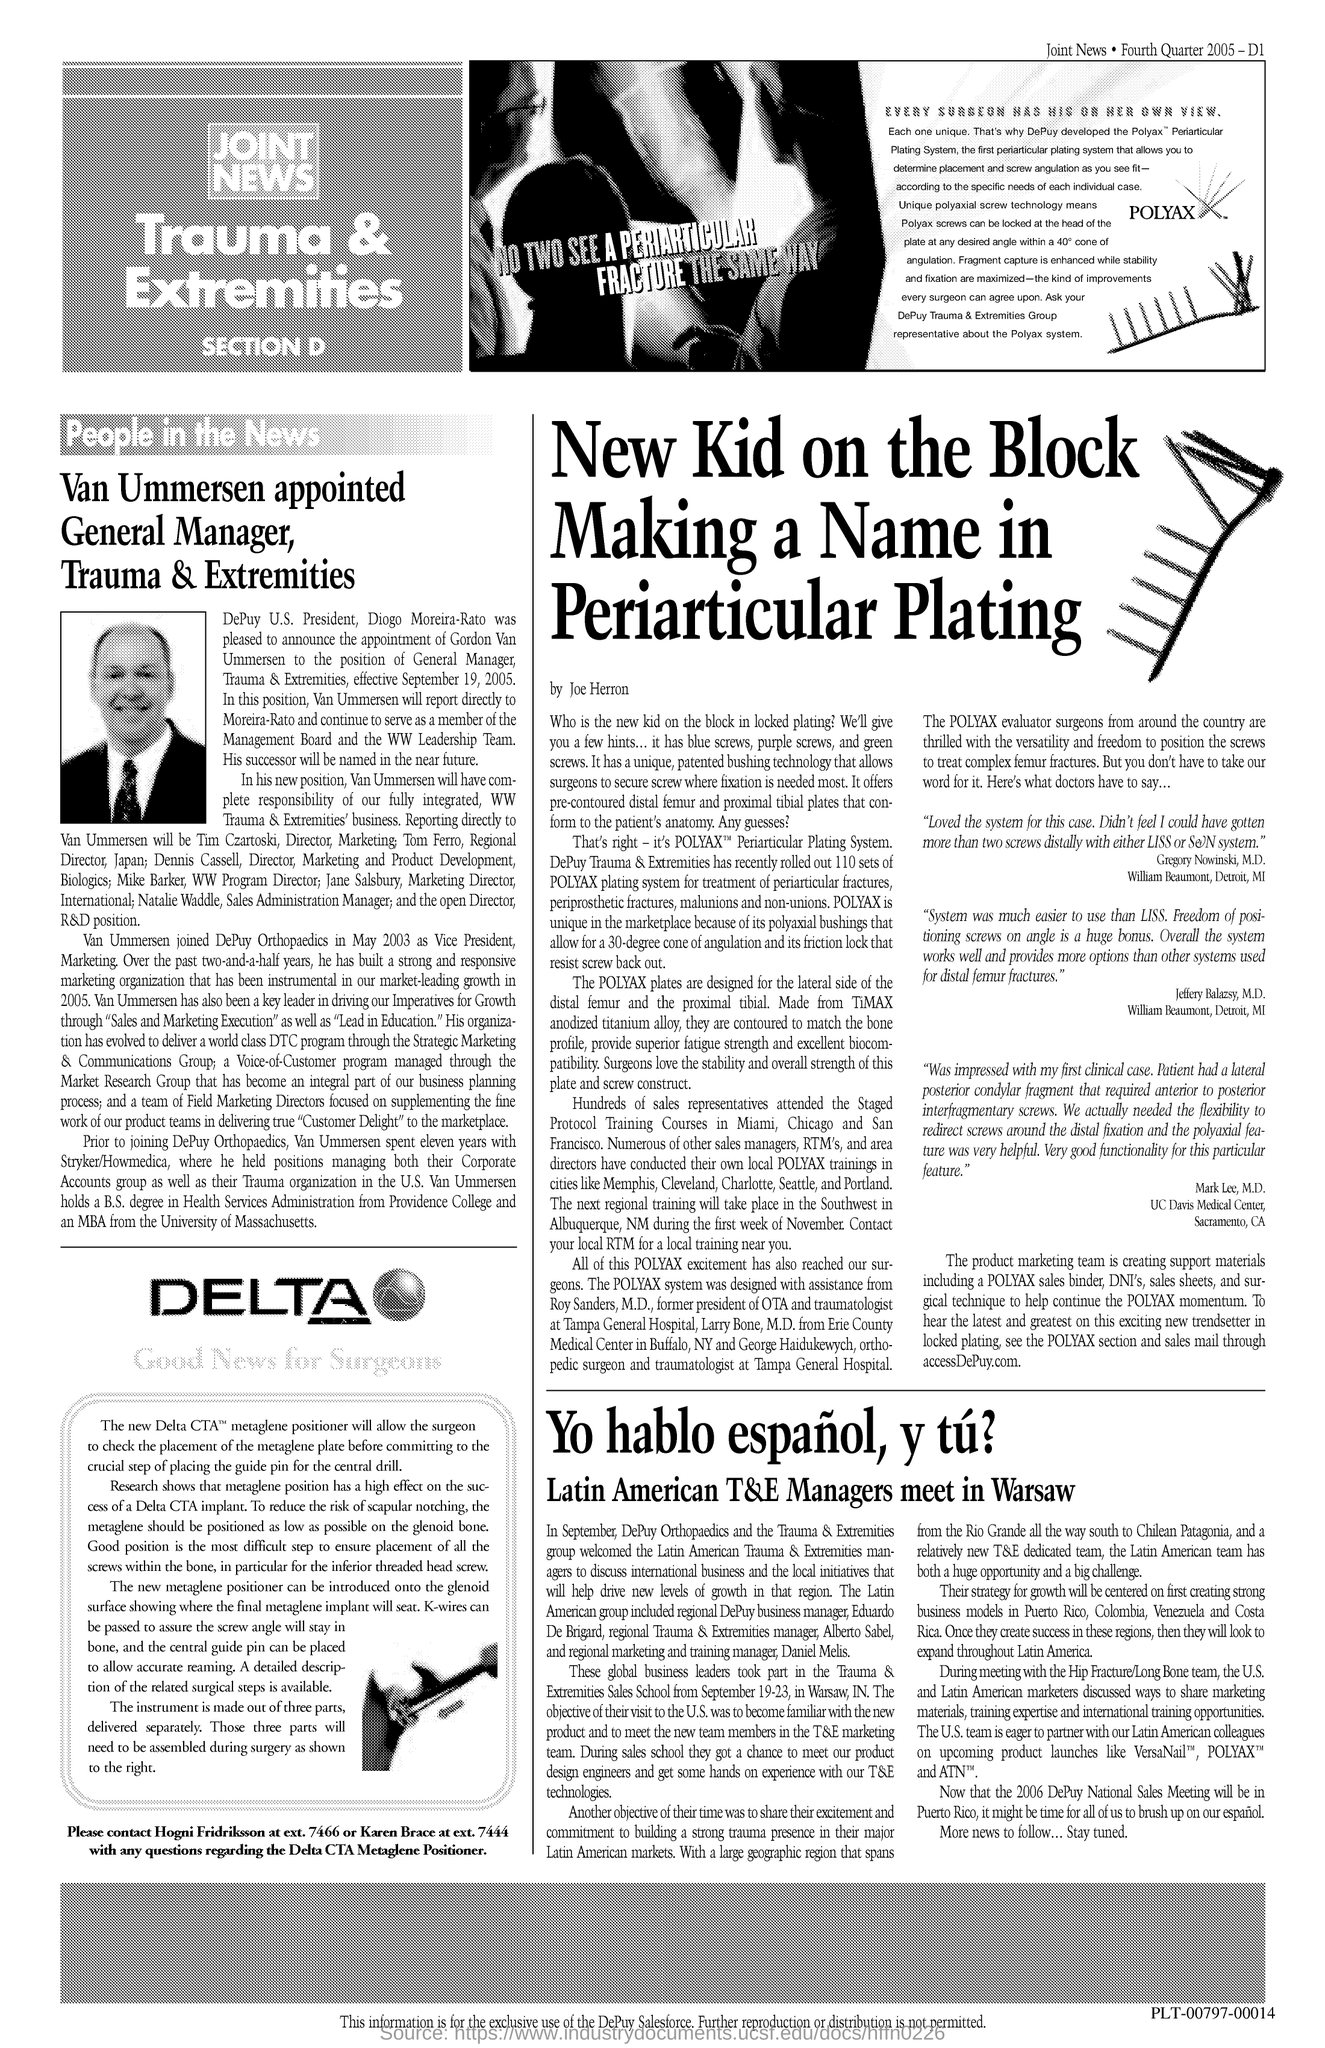Highlight a few significant elements in this photo. Van Ummersen is the General Manager of Trauma & Extremities. 